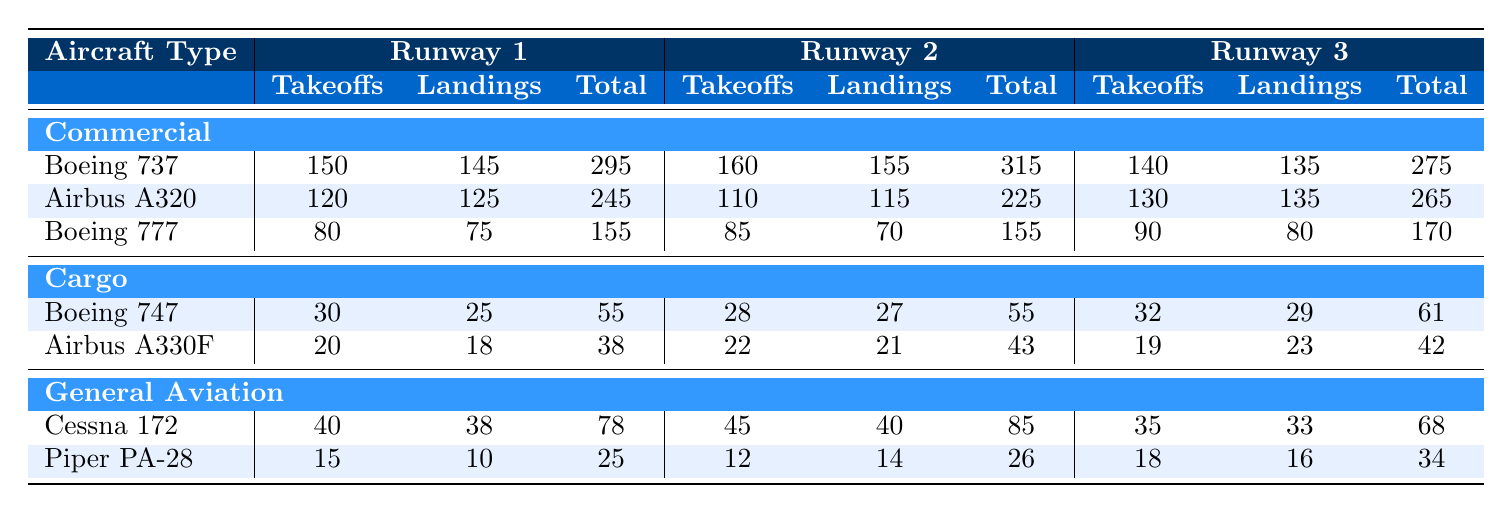What is the total number of takeoffs for Boeing 737 across all runways? For Boeing 737, the takeoff counts are: Runway 1 has 150, Runway 2 has 160, and Runway 3 has 140. Therefore, the total is 150 + 160 + 140 = 450.
Answer: 450 What is the total number of landings for Cargo aircraft across all runways? The landing counts for Cargo are: Runway 1 has 25 for Boeing 747 and 18 for Airbus A330F, total 25 + 18 = 43; Runway 2 has 27 and 21, total 27 + 21 = 48; Runway 3 has 29 and 23, total 29 + 23 = 52. Now summing all the totals: 43 + 48 + 52 = 143.
Answer: 143 Which runway had the highest total landings for Airbus A320? The landings for Airbus A320 are: Runway 1 has 125, Runway 2 has 115, and Runway 3 has 135. The highest value is 135, which is for Runway 3.
Answer: Runway 3 What is the difference in total landings between Runway 1 and Runway 2 for Commercial aircraft? For Runway 1: total landings for Commercial is 145 + 125 + 75 = 345. For Runway 2: total landings is 155 + 115 + 70 = 340. The difference is 345 - 340 = 5.
Answer: 5 What is the total number of movements (takeoffs and landings) for Cessna 172 across all runways? The takeoff count for Cessna 172 is 40 (Runway 1) + 45 (Runway 2) + 35 (Runway 3) = 120. The landing counts are 38 + 40 + 33 = 111. Therefore, total movements is 120 + 111 = 231.
Answer: 231 Is there any runway where the total takeoffs for General Aviation exceed those for Cargo? For Runway 1, General Aviation (55 total) exceeds Cargo (55 total); For Runway 2, General Aviation (85 total) exceeds Cargo (43 total); For Runway 3, General Aviation (68 total) also exceeds Cargo (61 total). So yes, all runways meet the condition.
Answer: Yes What is the average number of takeoffs for the Airbus A320 across all runways? Count of takeoffs for Airbus A320 is: 120 (Runway 1), 110 (Runway 2), and 130 (Runway 3); sum them gives 120 + 110 + 130 = 360. The average is 360/3 = 120.
Answer: 120 Which type of aircraft had fewer total movements: Cargo or General Aviation? Total movements for Cargo: 55 (Boeing 747) + 43 (Airbus A330F) = 98. Total movements for General Aviation: 231. Cargo has fewer movements, 98 < 231.
Answer: Cargo How many more takeoffs does Runway 2 have compared to Runway 1 for Boeing 747? The takeoff counts for Boeing 747 are: Runway 1 has 30 and Runway 2 has 28. The difference is 30 - 28 = 2, indicating Runway 1 has more.
Answer: 2 